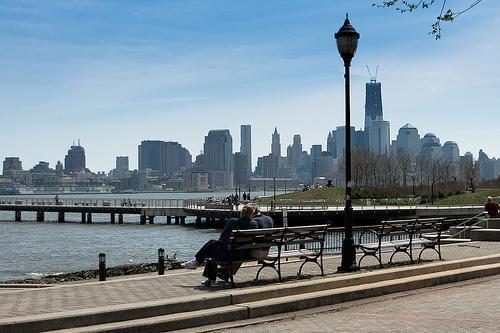How many people sitting on a bench?
Give a very brief answer. 2. 